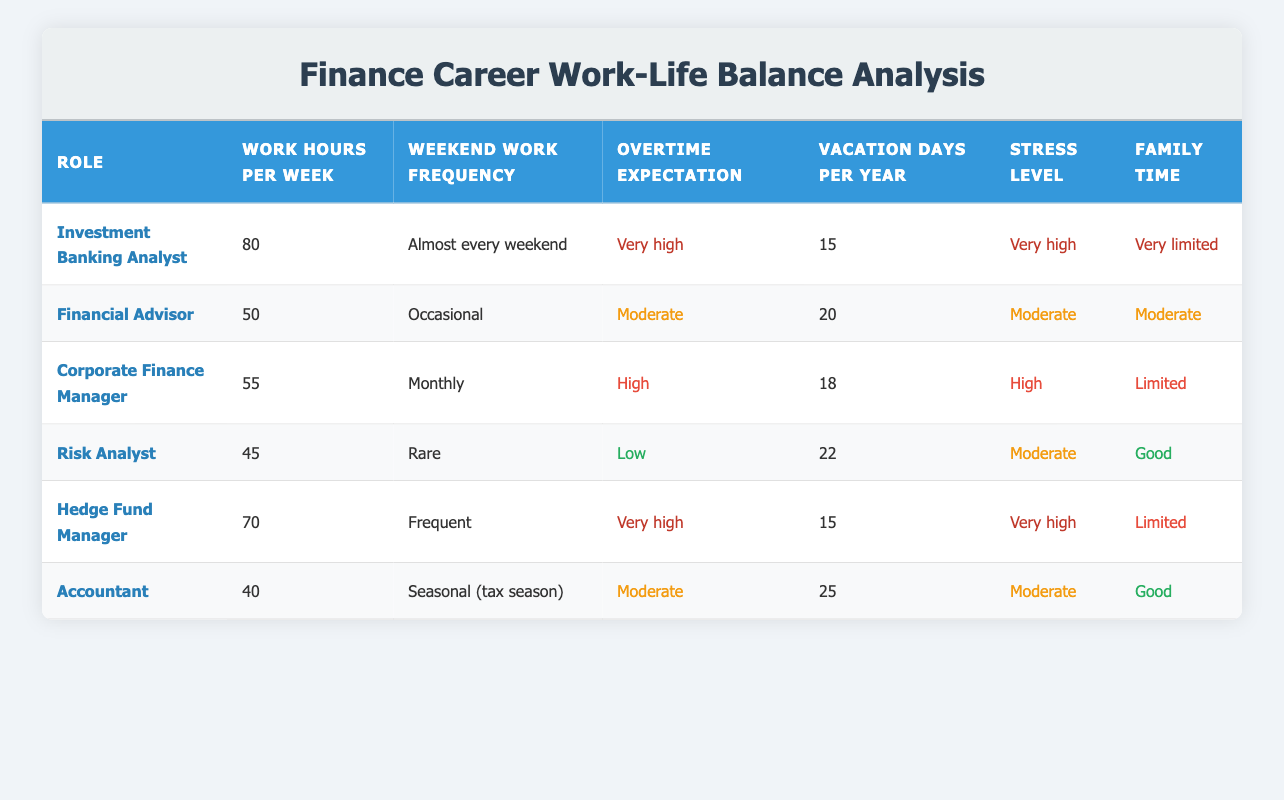What is the average work hours per week for Corporate Finance Manager and Financial Advisor? The work hours for Corporate Finance Manager is 55 and for Financial Advisor is 50. To find the average, add the two values: 55 + 50 = 105, then divide by 2 (the number of roles): 105 / 2 = 52.5
Answer: 52.5 How many vacation days does a Risk Analyst have per year? The table shows that a Risk Analyst has 22 vacation days per year, as stated directly under the "Vacation days per year" column for this role.
Answer: 22 Is the stress level for Hedge Fund Manager categorized as high? The stress level for Hedge Fund Manager is listed as "Very high," which does not categorize it as "High." Therefore, the answer is no.
Answer: No Which finance role has the least amount of family time, and what is the family time classification? The Investment Banking Analyst role has the "Very limited" family time classification, which is clearly indicated in the last column of the corresponding row.
Answer: Investment Banking Analyst; Very limited What is the difference in vacation days per year between an Accountant and an Investment Banking Analyst? The Accountant has 25 vacation days, while the Investment Banking Analyst has 15. The difference is calculated by subtracting the smaller number from the larger one: 25 - 15 = 10.
Answer: 10 Does an Investment Banking Analyst typically work on weekends? Yes, the table specifies that an Investment Banking Analyst works almost every weekend, confirming that weekend work is expected.
Answer: Yes What is the total work hours per week for all six roles combined? The work hours for all roles are as follows: 80 (Investment Banking Analyst) + 50 (Financial Advisor) + 55 (Corporate Finance Manager) + 45 (Risk Analyst) + 70 (Hedge Fund Manager) + 40 (Accountant) = 340. So, the total work hours for all roles combined is 340.
Answer: 340 Which role has the highest stress level and what is that level? The roles are assessed, and both Investment Banking Analyst and Hedge Fund Manager are classified under "Very high" stress level; however, they share this classification. Therefore, they both have the same highest level of stress.
Answer: Investment Banking Analyst and Hedge Fund Manager; Very high What percentage of the finance roles listed have a moderate stress level? There are six finance roles total. The Financial Advisor, Corporate Finance Manager, and Accountant are categorized under "Moderate" stress level, which counts as 3 roles. To find the percentage: (3 / 6) * 100 = 50 percent.
Answer: 50 percent 